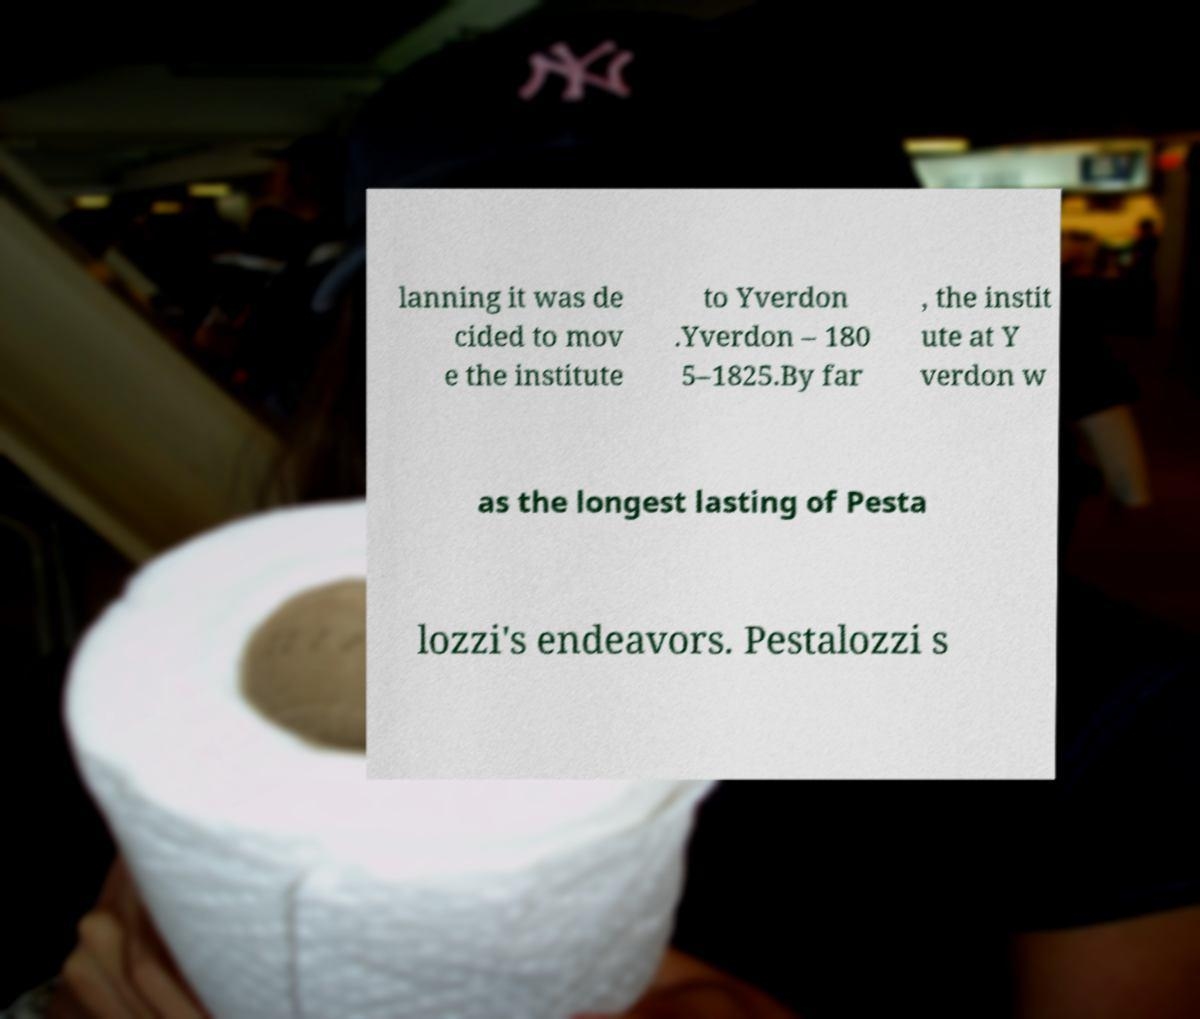Can you read and provide the text displayed in the image?This photo seems to have some interesting text. Can you extract and type it out for me? lanning it was de cided to mov e the institute to Yverdon .Yverdon – 180 5–1825.By far , the instit ute at Y verdon w as the longest lasting of Pesta lozzi's endeavors. Pestalozzi s 